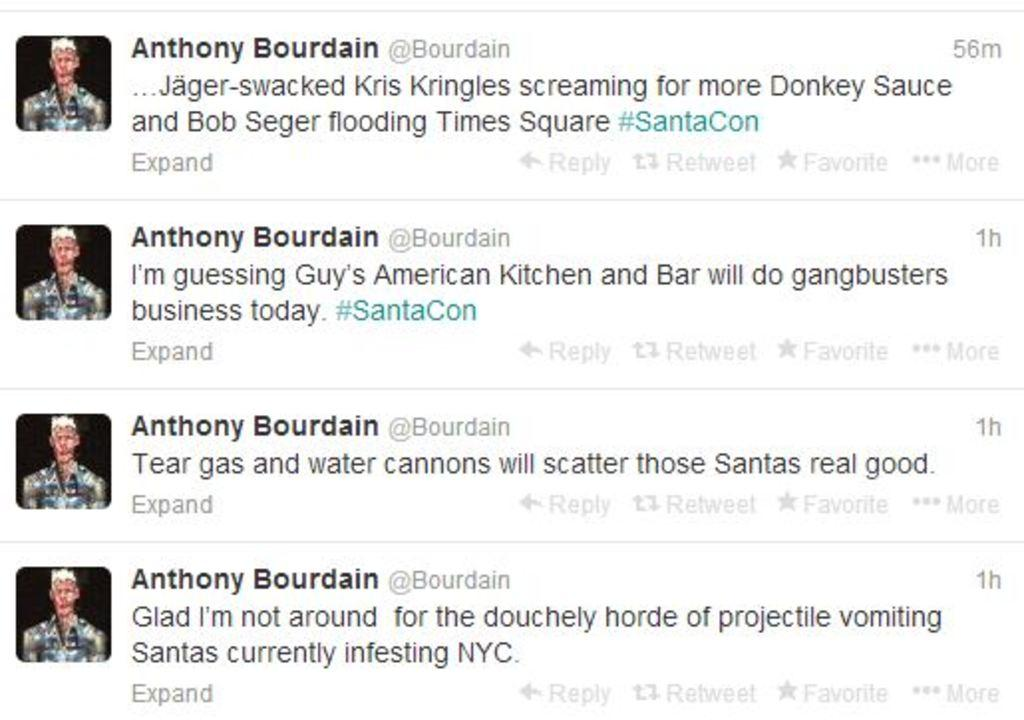What type of page is shown in the image? There is a notification page in the image. What can be found on the notification page? There is text and pictures present on the notification page. How many cows are visible in the image? There are no cows present in the image; it features a notification page with text and pictures. Is it raining in the image? There is no indication of rain in the image, as it features a notification page with text and pictures. 